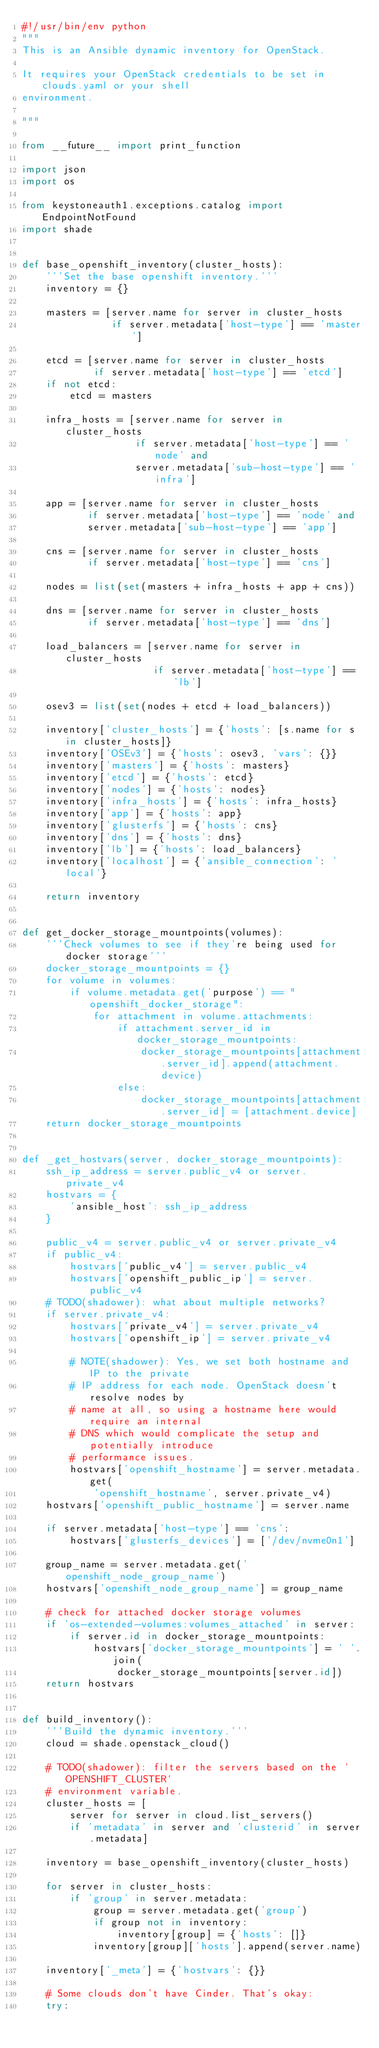<code> <loc_0><loc_0><loc_500><loc_500><_Python_>#!/usr/bin/env python
"""
This is an Ansible dynamic inventory for OpenStack.

It requires your OpenStack credentials to be set in clouds.yaml or your shell
environment.

"""

from __future__ import print_function

import json
import os

from keystoneauth1.exceptions.catalog import EndpointNotFound
import shade


def base_openshift_inventory(cluster_hosts):
    '''Set the base openshift inventory.'''
    inventory = {}

    masters = [server.name for server in cluster_hosts
               if server.metadata['host-type'] == 'master']

    etcd = [server.name for server in cluster_hosts
            if server.metadata['host-type'] == 'etcd']
    if not etcd:
        etcd = masters

    infra_hosts = [server.name for server in cluster_hosts
                   if server.metadata['host-type'] == 'node' and
                   server.metadata['sub-host-type'] == 'infra']

    app = [server.name for server in cluster_hosts
           if server.metadata['host-type'] == 'node' and
           server.metadata['sub-host-type'] == 'app']

    cns = [server.name for server in cluster_hosts
           if server.metadata['host-type'] == 'cns']

    nodes = list(set(masters + infra_hosts + app + cns))

    dns = [server.name for server in cluster_hosts
           if server.metadata['host-type'] == 'dns']

    load_balancers = [server.name for server in cluster_hosts
                      if server.metadata['host-type'] == 'lb']

    osev3 = list(set(nodes + etcd + load_balancers))

    inventory['cluster_hosts'] = {'hosts': [s.name for s in cluster_hosts]}
    inventory['OSEv3'] = {'hosts': osev3, 'vars': {}}
    inventory['masters'] = {'hosts': masters}
    inventory['etcd'] = {'hosts': etcd}
    inventory['nodes'] = {'hosts': nodes}
    inventory['infra_hosts'] = {'hosts': infra_hosts}
    inventory['app'] = {'hosts': app}
    inventory['glusterfs'] = {'hosts': cns}
    inventory['dns'] = {'hosts': dns}
    inventory['lb'] = {'hosts': load_balancers}
    inventory['localhost'] = {'ansible_connection': 'local'}

    return inventory


def get_docker_storage_mountpoints(volumes):
    '''Check volumes to see if they're being used for docker storage'''
    docker_storage_mountpoints = {}
    for volume in volumes:
        if volume.metadata.get('purpose') == "openshift_docker_storage":
            for attachment in volume.attachments:
                if attachment.server_id in docker_storage_mountpoints:
                    docker_storage_mountpoints[attachment.server_id].append(attachment.device)
                else:
                    docker_storage_mountpoints[attachment.server_id] = [attachment.device]
    return docker_storage_mountpoints


def _get_hostvars(server, docker_storage_mountpoints):
    ssh_ip_address = server.public_v4 or server.private_v4
    hostvars = {
        'ansible_host': ssh_ip_address
    }

    public_v4 = server.public_v4 or server.private_v4
    if public_v4:
        hostvars['public_v4'] = server.public_v4
        hostvars['openshift_public_ip'] = server.public_v4
    # TODO(shadower): what about multiple networks?
    if server.private_v4:
        hostvars['private_v4'] = server.private_v4
        hostvars['openshift_ip'] = server.private_v4

        # NOTE(shadower): Yes, we set both hostname and IP to the private
        # IP address for each node. OpenStack doesn't resolve nodes by
        # name at all, so using a hostname here would require an internal
        # DNS which would complicate the setup and potentially introduce
        # performance issues.
        hostvars['openshift_hostname'] = server.metadata.get(
            'openshift_hostname', server.private_v4)
    hostvars['openshift_public_hostname'] = server.name

    if server.metadata['host-type'] == 'cns':
        hostvars['glusterfs_devices'] = ['/dev/nvme0n1']

    group_name = server.metadata.get('openshift_node_group_name')
    hostvars['openshift_node_group_name'] = group_name

    # check for attached docker storage volumes
    if 'os-extended-volumes:volumes_attached' in server:
        if server.id in docker_storage_mountpoints:
            hostvars['docker_storage_mountpoints'] = ' '.join(
                docker_storage_mountpoints[server.id])
    return hostvars


def build_inventory():
    '''Build the dynamic inventory.'''
    cloud = shade.openstack_cloud()

    # TODO(shadower): filter the servers based on the `OPENSHIFT_CLUSTER`
    # environment variable.
    cluster_hosts = [
        server for server in cloud.list_servers()
        if 'metadata' in server and 'clusterid' in server.metadata]

    inventory = base_openshift_inventory(cluster_hosts)

    for server in cluster_hosts:
        if 'group' in server.metadata:
            group = server.metadata.get('group')
            if group not in inventory:
                inventory[group] = {'hosts': []}
            inventory[group]['hosts'].append(server.name)

    inventory['_meta'] = {'hostvars': {}}

    # Some clouds don't have Cinder. That's okay:
    try:</code> 